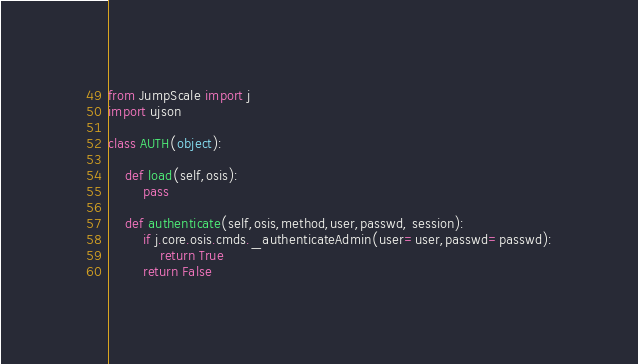<code> <loc_0><loc_0><loc_500><loc_500><_Python_>from JumpScale import j
import ujson

class AUTH(object):

    def load(self,osis):
        pass

    def authenticate(self,osis,method,user,passwd, session):
        if j.core.osis.cmds._authenticateAdmin(user=user,passwd=passwd):
            return True
        return False
</code> 